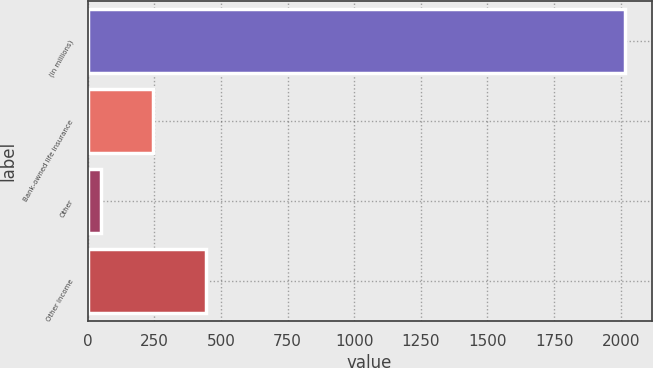<chart> <loc_0><loc_0><loc_500><loc_500><bar_chart><fcel>(in millions)<fcel>Bank-owned life insurance<fcel>Other<fcel>Other income<nl><fcel>2015<fcel>246.5<fcel>50<fcel>443<nl></chart> 